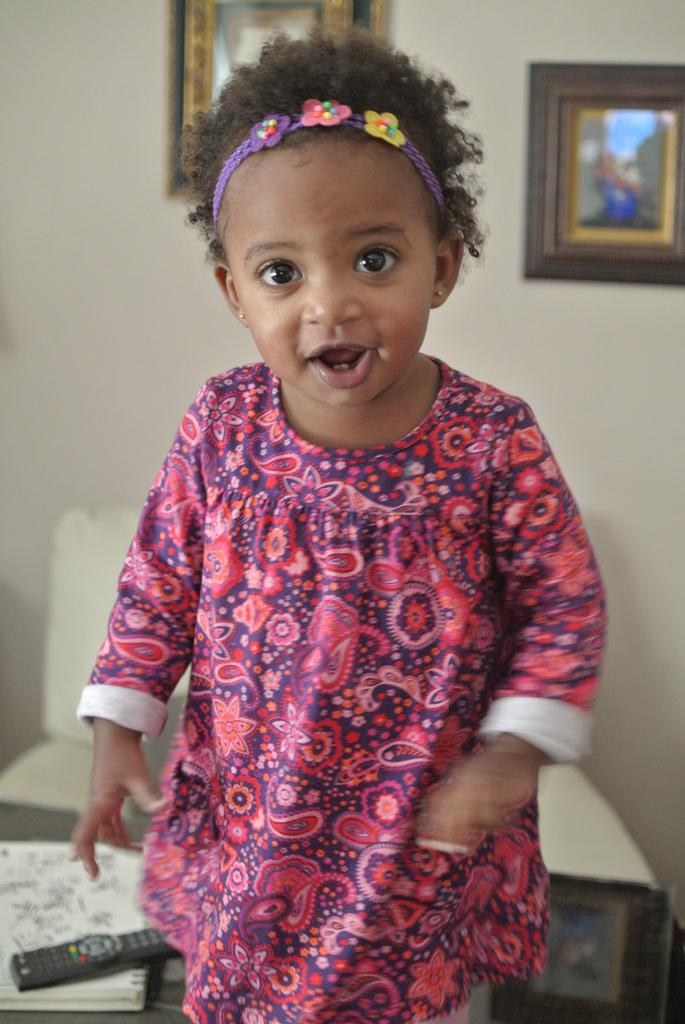What is the main subject of the image? There is a girl standing in the image. What object is placed on a book in the image? There is a remote on a book in the image. What type of furniture is present in the image? There is a chair in the image. What can be seen on the wall in the background of the image? There are frames attached to the wall in the background of the image. What type of poison is the girl holding in the image? There is no poison present in the image; the girl is not holding any such object. 